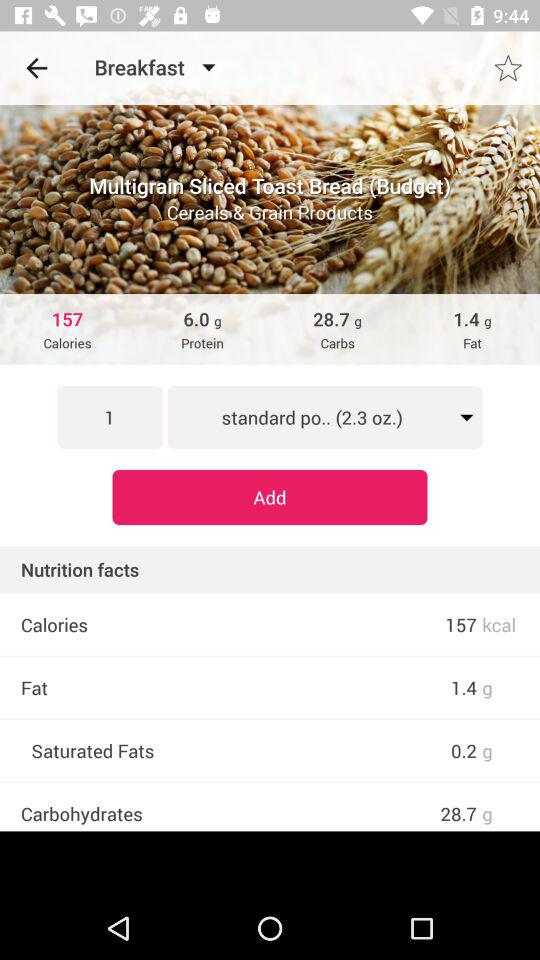How many grams of carbs are in 1 serving?
Answer the question using a single word or phrase. 28.7 